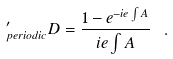Convert formula to latex. <formula><loc_0><loc_0><loc_500><loc_500>^ { \prime } _ { p e r i o d i c } D = \frac { 1 - e ^ { - i e \int A } } { i e \int A } \ .</formula> 